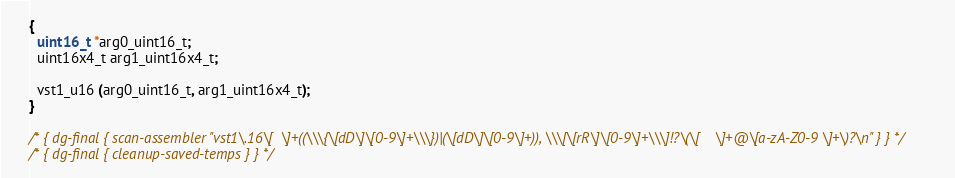Convert code to text. <code><loc_0><loc_0><loc_500><loc_500><_C_>{
  uint16_t *arg0_uint16_t;
  uint16x4_t arg1_uint16x4_t;

  vst1_u16 (arg0_uint16_t, arg1_uint16x4_t);
}

/* { dg-final { scan-assembler "vst1\.16\[ 	\]+((\\\{\[dD\]\[0-9\]+\\\})|(\[dD\]\[0-9\]+)), \\\[\[rR\]\[0-9\]+\\\]!?\(\[ 	\]+@\[a-zA-Z0-9 \]+\)?\n" } } */
/* { dg-final { cleanup-saved-temps } } */
</code> 